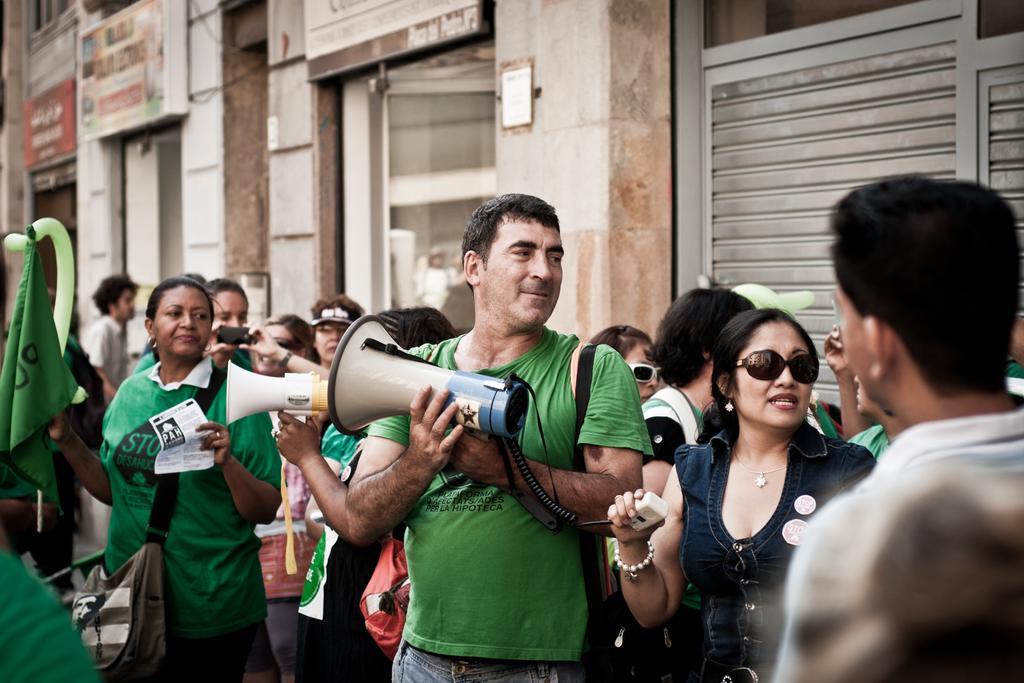In one or two sentences, can you explain what this image depicts? Here we can see people. These two people are holding hand speakers. This woman wore bag, holding poster in one hand and with the other hand she is holding a flag. Another woman is holding an object. Background we can see hoardings on wall.  